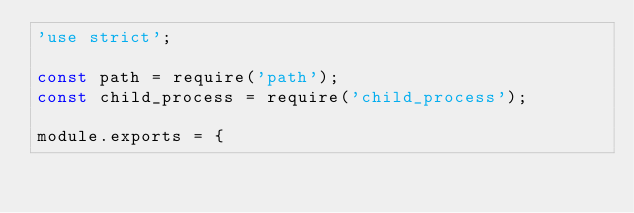<code> <loc_0><loc_0><loc_500><loc_500><_JavaScript_>'use strict';

const path = require('path');
const child_process = require('child_process');

module.exports = {</code> 